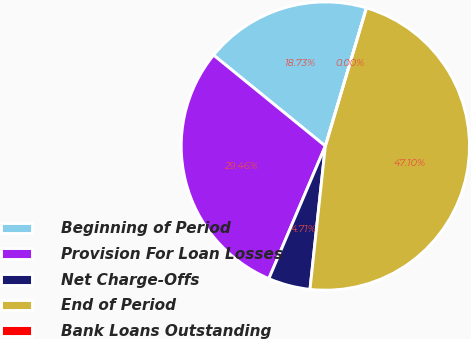<chart> <loc_0><loc_0><loc_500><loc_500><pie_chart><fcel>Beginning of Period<fcel>Provision For Loan Losses<fcel>Net Charge-Offs<fcel>End of Period<fcel>Bank Loans Outstanding<nl><fcel>18.73%<fcel>29.46%<fcel>4.71%<fcel>47.1%<fcel>0.0%<nl></chart> 